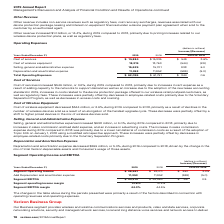According to Verizon Communications's financial document, How much did Cost of services increase in 2019? According to the financial document, $549 million. The relevant text states: "Cost of services increased $549 million, or 3.6%, during 2019 compared to 2018, primarily due to increases in rent expense as a result of a..." Also, What is the total operating expenses in 2019? According to the financial document, $ 62,095 (in millions). The relevant text states: "Total Operating Expenses $ 62,095 $ 61,751 $ 344 0.6..." Also, How much did Cost of wireless equipment decrease in 2019? According to the financial document, $544 million. The relevant text states: "Cost of wireless equipment decreased $544 million, or 2.9%, during 2019 compared to 2018, primarily as a result of declines in the number of wireless..." Also, can you calculate: What is the change in Cost of services from 2018 to 2019? Based on the calculation: 15,884-15,335, the result is 549 (in millions). This is based on the information: "Cost of services $ 15,884 $ 15,335 $ 549 3.6% Cost of services $ 15,884 $ 15,335 $ 549 3.6%..." The key data points involved are: 15,335, 15,884. Also, can you calculate: What is the change in Cost of wireless equipment from 2018 to 2019? Based on the calculation: 18,219-18,763, the result is -544 (in millions). This is based on the information: "Cost of wireless equipment 18,219 18,763 (544) (2.9) Cost of wireless equipment 18,219 18,763 (544) (2.9)..." The key data points involved are: 18,219, 18,763. Also, can you calculate: What is the change in Total Operating Expenses from 2018 to 2019? Based on the calculation: 62,095-61,751, the result is 344 (in millions). This is based on the information: "Total Operating Expenses $ 62,095 $ 61,751 $ 344 0.6 Total Operating Expenses $ 62,095 $ 61,751 $ 344 0.6..." The key data points involved are: 61,751, 62,095. 